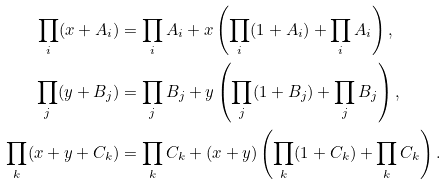Convert formula to latex. <formula><loc_0><loc_0><loc_500><loc_500>\prod _ { i } ( x + A _ { i } ) & = \prod _ { i } A _ { i } + x \left ( \prod _ { i } ( 1 + A _ { i } ) + \prod _ { i } A _ { i } \right ) , \\ \prod _ { j } ( y + B _ { j } ) & = \prod _ { j } B _ { j } + y \left ( \prod _ { j } ( 1 + B _ { j } ) + \prod _ { j } B _ { j } \right ) , \\ \prod _ { k } ( x + y + C _ { k } ) & = \prod _ { k } C _ { k } + ( x + y ) \left ( \prod _ { k } ( 1 + C _ { k } ) + \prod _ { k } C _ { k } \right ) .</formula> 